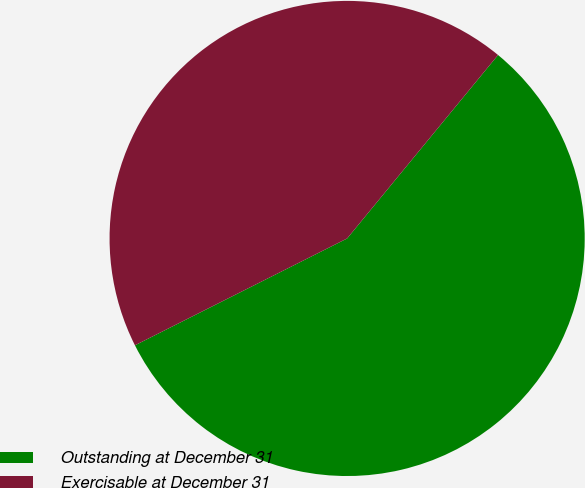Convert chart. <chart><loc_0><loc_0><loc_500><loc_500><pie_chart><fcel>Outstanding at December 31<fcel>Exercisable at December 31<nl><fcel>56.62%<fcel>43.38%<nl></chart> 